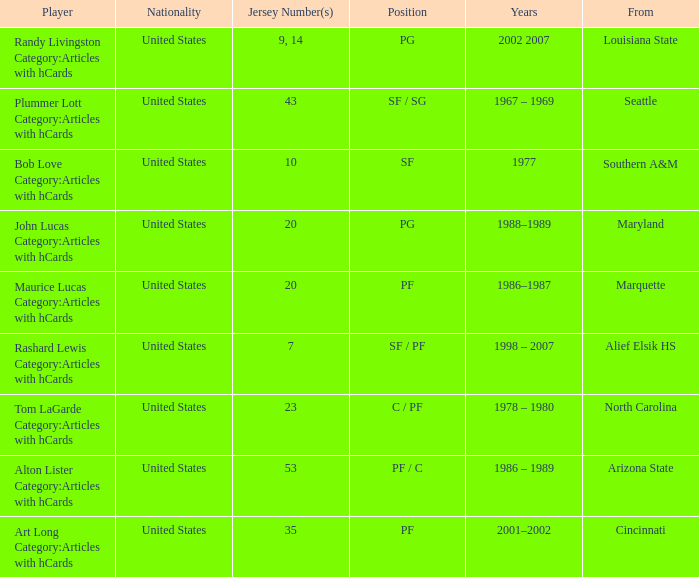The player from Alief Elsik Hs has what as a nationality? United States. 